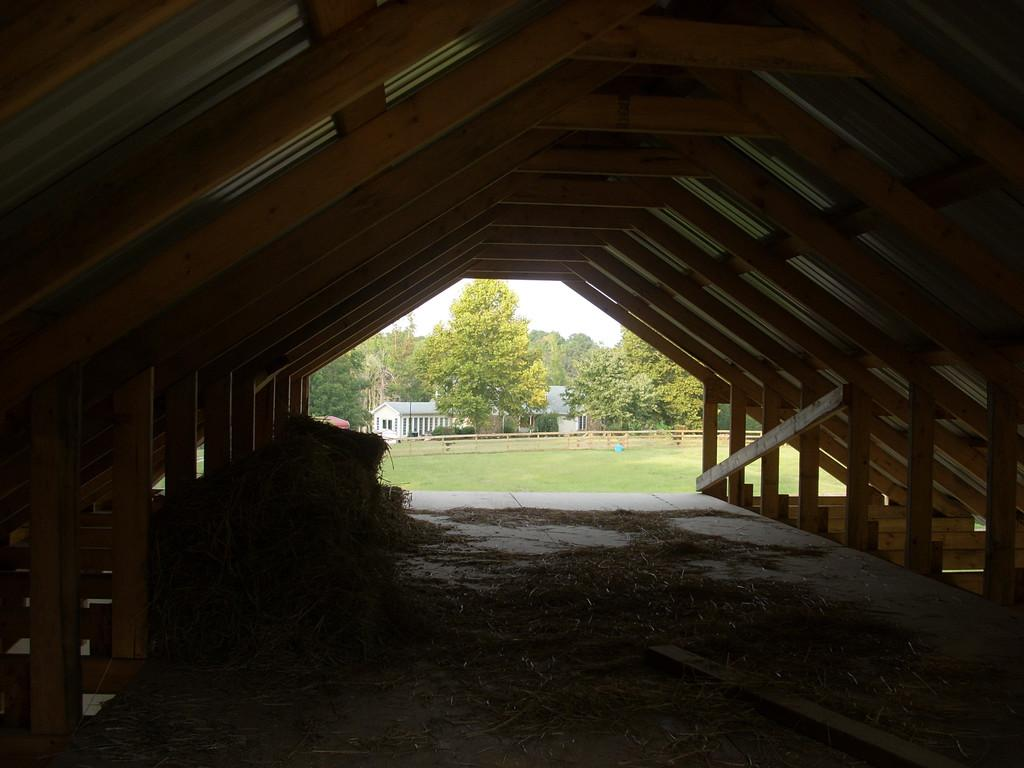What type of structure is present in the image? There is a shed in the image. What is on the floor inside the shed? There is grass on the floor in the image. What can be seen in the background of the image? There is ground, railing, green trees, buildings, and the sky visible in the background of the image. How many jellyfish are swimming in the shed in the image? There are no jellyfish present in the image, as it features a shed with grass on the floor and various elements in the background. 